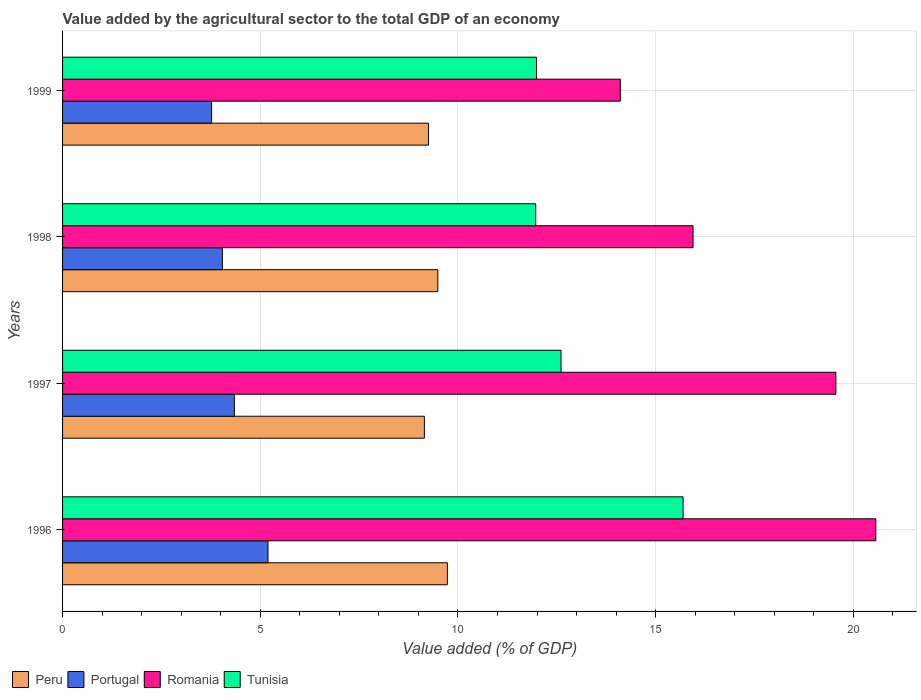Are the number of bars per tick equal to the number of legend labels?
Provide a short and direct response. Yes. Are the number of bars on each tick of the Y-axis equal?
Ensure brevity in your answer.  Yes. How many bars are there on the 1st tick from the top?
Make the answer very short. 4. What is the label of the 4th group of bars from the top?
Provide a short and direct response. 1996. In how many cases, is the number of bars for a given year not equal to the number of legend labels?
Give a very brief answer. 0. What is the value added by the agricultural sector to the total GDP in Romania in 1998?
Ensure brevity in your answer.  15.94. Across all years, what is the maximum value added by the agricultural sector to the total GDP in Tunisia?
Make the answer very short. 15.69. Across all years, what is the minimum value added by the agricultural sector to the total GDP in Tunisia?
Your response must be concise. 11.97. What is the total value added by the agricultural sector to the total GDP in Tunisia in the graph?
Give a very brief answer. 52.25. What is the difference between the value added by the agricultural sector to the total GDP in Portugal in 1996 and that in 1999?
Offer a terse response. 1.43. What is the difference between the value added by the agricultural sector to the total GDP in Peru in 1997 and the value added by the agricultural sector to the total GDP in Portugal in 1999?
Keep it short and to the point. 5.38. What is the average value added by the agricultural sector to the total GDP in Portugal per year?
Offer a terse response. 4.34. In the year 1998, what is the difference between the value added by the agricultural sector to the total GDP in Romania and value added by the agricultural sector to the total GDP in Peru?
Give a very brief answer. 6.45. What is the ratio of the value added by the agricultural sector to the total GDP in Tunisia in 1996 to that in 1998?
Offer a very short reply. 1.31. Is the difference between the value added by the agricultural sector to the total GDP in Romania in 1998 and 1999 greater than the difference between the value added by the agricultural sector to the total GDP in Peru in 1998 and 1999?
Provide a succinct answer. Yes. What is the difference between the highest and the second highest value added by the agricultural sector to the total GDP in Tunisia?
Give a very brief answer. 3.09. What is the difference between the highest and the lowest value added by the agricultural sector to the total GDP in Portugal?
Your answer should be compact. 1.43. Is the sum of the value added by the agricultural sector to the total GDP in Romania in 1998 and 1999 greater than the maximum value added by the agricultural sector to the total GDP in Peru across all years?
Make the answer very short. Yes. Is it the case that in every year, the sum of the value added by the agricultural sector to the total GDP in Romania and value added by the agricultural sector to the total GDP in Peru is greater than the sum of value added by the agricultural sector to the total GDP in Tunisia and value added by the agricultural sector to the total GDP in Portugal?
Give a very brief answer. Yes. What does the 2nd bar from the top in 1998 represents?
Make the answer very short. Romania. What does the 3rd bar from the bottom in 1996 represents?
Ensure brevity in your answer.  Romania. How many bars are there?
Your answer should be very brief. 16. Are all the bars in the graph horizontal?
Make the answer very short. Yes. How many years are there in the graph?
Ensure brevity in your answer.  4. What is the difference between two consecutive major ticks on the X-axis?
Provide a succinct answer. 5. Are the values on the major ticks of X-axis written in scientific E-notation?
Provide a succinct answer. No. Does the graph contain grids?
Your response must be concise. Yes. How are the legend labels stacked?
Make the answer very short. Horizontal. What is the title of the graph?
Your answer should be compact. Value added by the agricultural sector to the total GDP of an economy. What is the label or title of the X-axis?
Keep it short and to the point. Value added (% of GDP). What is the label or title of the Y-axis?
Your answer should be very brief. Years. What is the Value added (% of GDP) of Peru in 1996?
Give a very brief answer. 9.73. What is the Value added (% of GDP) of Portugal in 1996?
Your response must be concise. 5.2. What is the Value added (% of GDP) of Romania in 1996?
Your answer should be compact. 20.57. What is the Value added (% of GDP) of Tunisia in 1996?
Make the answer very short. 15.69. What is the Value added (% of GDP) in Peru in 1997?
Your answer should be very brief. 9.15. What is the Value added (% of GDP) of Portugal in 1997?
Provide a short and direct response. 4.34. What is the Value added (% of GDP) of Romania in 1997?
Offer a very short reply. 19.56. What is the Value added (% of GDP) in Tunisia in 1997?
Offer a very short reply. 12.61. What is the Value added (% of GDP) in Peru in 1998?
Ensure brevity in your answer.  9.49. What is the Value added (% of GDP) of Portugal in 1998?
Your answer should be very brief. 4.04. What is the Value added (% of GDP) in Romania in 1998?
Provide a succinct answer. 15.94. What is the Value added (% of GDP) in Tunisia in 1998?
Keep it short and to the point. 11.97. What is the Value added (% of GDP) in Peru in 1999?
Offer a terse response. 9.25. What is the Value added (% of GDP) of Portugal in 1999?
Offer a very short reply. 3.77. What is the Value added (% of GDP) in Romania in 1999?
Your response must be concise. 14.11. What is the Value added (% of GDP) in Tunisia in 1999?
Ensure brevity in your answer.  11.99. Across all years, what is the maximum Value added (% of GDP) of Peru?
Offer a terse response. 9.73. Across all years, what is the maximum Value added (% of GDP) in Portugal?
Provide a short and direct response. 5.2. Across all years, what is the maximum Value added (% of GDP) of Romania?
Provide a succinct answer. 20.57. Across all years, what is the maximum Value added (% of GDP) in Tunisia?
Provide a short and direct response. 15.69. Across all years, what is the minimum Value added (% of GDP) of Peru?
Your answer should be very brief. 9.15. Across all years, what is the minimum Value added (% of GDP) in Portugal?
Offer a terse response. 3.77. Across all years, what is the minimum Value added (% of GDP) of Romania?
Your response must be concise. 14.11. Across all years, what is the minimum Value added (% of GDP) in Tunisia?
Make the answer very short. 11.97. What is the total Value added (% of GDP) of Peru in the graph?
Your answer should be compact. 37.63. What is the total Value added (% of GDP) in Portugal in the graph?
Make the answer very short. 17.35. What is the total Value added (% of GDP) in Romania in the graph?
Ensure brevity in your answer.  70.18. What is the total Value added (% of GDP) of Tunisia in the graph?
Keep it short and to the point. 52.25. What is the difference between the Value added (% of GDP) in Peru in 1996 and that in 1997?
Provide a succinct answer. 0.58. What is the difference between the Value added (% of GDP) of Portugal in 1996 and that in 1997?
Ensure brevity in your answer.  0.85. What is the difference between the Value added (% of GDP) in Romania in 1996 and that in 1997?
Your answer should be compact. 1.01. What is the difference between the Value added (% of GDP) of Tunisia in 1996 and that in 1997?
Make the answer very short. 3.09. What is the difference between the Value added (% of GDP) in Peru in 1996 and that in 1998?
Your answer should be compact. 0.24. What is the difference between the Value added (% of GDP) in Portugal in 1996 and that in 1998?
Keep it short and to the point. 1.15. What is the difference between the Value added (% of GDP) in Romania in 1996 and that in 1998?
Your response must be concise. 4.62. What is the difference between the Value added (% of GDP) of Tunisia in 1996 and that in 1998?
Provide a short and direct response. 3.73. What is the difference between the Value added (% of GDP) of Peru in 1996 and that in 1999?
Give a very brief answer. 0.48. What is the difference between the Value added (% of GDP) of Portugal in 1996 and that in 1999?
Your response must be concise. 1.43. What is the difference between the Value added (% of GDP) in Romania in 1996 and that in 1999?
Make the answer very short. 6.46. What is the difference between the Value added (% of GDP) of Tunisia in 1996 and that in 1999?
Keep it short and to the point. 3.71. What is the difference between the Value added (% of GDP) of Peru in 1997 and that in 1998?
Make the answer very short. -0.34. What is the difference between the Value added (% of GDP) in Portugal in 1997 and that in 1998?
Your answer should be compact. 0.3. What is the difference between the Value added (% of GDP) of Romania in 1997 and that in 1998?
Keep it short and to the point. 3.61. What is the difference between the Value added (% of GDP) in Tunisia in 1997 and that in 1998?
Your answer should be very brief. 0.64. What is the difference between the Value added (% of GDP) in Peru in 1997 and that in 1999?
Make the answer very short. -0.1. What is the difference between the Value added (% of GDP) in Portugal in 1997 and that in 1999?
Your answer should be very brief. 0.58. What is the difference between the Value added (% of GDP) in Romania in 1997 and that in 1999?
Keep it short and to the point. 5.45. What is the difference between the Value added (% of GDP) of Tunisia in 1997 and that in 1999?
Your answer should be very brief. 0.62. What is the difference between the Value added (% of GDP) of Peru in 1998 and that in 1999?
Ensure brevity in your answer.  0.24. What is the difference between the Value added (% of GDP) of Portugal in 1998 and that in 1999?
Your answer should be very brief. 0.27. What is the difference between the Value added (% of GDP) of Romania in 1998 and that in 1999?
Your response must be concise. 1.84. What is the difference between the Value added (% of GDP) of Tunisia in 1998 and that in 1999?
Provide a succinct answer. -0.02. What is the difference between the Value added (% of GDP) in Peru in 1996 and the Value added (% of GDP) in Portugal in 1997?
Your answer should be very brief. 5.39. What is the difference between the Value added (% of GDP) of Peru in 1996 and the Value added (% of GDP) of Romania in 1997?
Provide a succinct answer. -9.83. What is the difference between the Value added (% of GDP) in Peru in 1996 and the Value added (% of GDP) in Tunisia in 1997?
Ensure brevity in your answer.  -2.87. What is the difference between the Value added (% of GDP) of Portugal in 1996 and the Value added (% of GDP) of Romania in 1997?
Offer a very short reply. -14.36. What is the difference between the Value added (% of GDP) in Portugal in 1996 and the Value added (% of GDP) in Tunisia in 1997?
Your answer should be very brief. -7.41. What is the difference between the Value added (% of GDP) of Romania in 1996 and the Value added (% of GDP) of Tunisia in 1997?
Offer a terse response. 7.96. What is the difference between the Value added (% of GDP) in Peru in 1996 and the Value added (% of GDP) in Portugal in 1998?
Your response must be concise. 5.69. What is the difference between the Value added (% of GDP) in Peru in 1996 and the Value added (% of GDP) in Romania in 1998?
Your answer should be very brief. -6.21. What is the difference between the Value added (% of GDP) of Peru in 1996 and the Value added (% of GDP) of Tunisia in 1998?
Give a very brief answer. -2.23. What is the difference between the Value added (% of GDP) in Portugal in 1996 and the Value added (% of GDP) in Romania in 1998?
Ensure brevity in your answer.  -10.75. What is the difference between the Value added (% of GDP) of Portugal in 1996 and the Value added (% of GDP) of Tunisia in 1998?
Your answer should be compact. -6.77. What is the difference between the Value added (% of GDP) in Romania in 1996 and the Value added (% of GDP) in Tunisia in 1998?
Ensure brevity in your answer.  8.6. What is the difference between the Value added (% of GDP) of Peru in 1996 and the Value added (% of GDP) of Portugal in 1999?
Your answer should be very brief. 5.96. What is the difference between the Value added (% of GDP) of Peru in 1996 and the Value added (% of GDP) of Romania in 1999?
Your response must be concise. -4.37. What is the difference between the Value added (% of GDP) of Peru in 1996 and the Value added (% of GDP) of Tunisia in 1999?
Your answer should be very brief. -2.25. What is the difference between the Value added (% of GDP) in Portugal in 1996 and the Value added (% of GDP) in Romania in 1999?
Offer a terse response. -8.91. What is the difference between the Value added (% of GDP) in Portugal in 1996 and the Value added (% of GDP) in Tunisia in 1999?
Make the answer very short. -6.79. What is the difference between the Value added (% of GDP) of Romania in 1996 and the Value added (% of GDP) of Tunisia in 1999?
Your answer should be very brief. 8.58. What is the difference between the Value added (% of GDP) in Peru in 1997 and the Value added (% of GDP) in Portugal in 1998?
Provide a succinct answer. 5.11. What is the difference between the Value added (% of GDP) of Peru in 1997 and the Value added (% of GDP) of Romania in 1998?
Your answer should be compact. -6.79. What is the difference between the Value added (% of GDP) in Peru in 1997 and the Value added (% of GDP) in Tunisia in 1998?
Provide a short and direct response. -2.82. What is the difference between the Value added (% of GDP) of Portugal in 1997 and the Value added (% of GDP) of Romania in 1998?
Give a very brief answer. -11.6. What is the difference between the Value added (% of GDP) of Portugal in 1997 and the Value added (% of GDP) of Tunisia in 1998?
Your response must be concise. -7.62. What is the difference between the Value added (% of GDP) of Romania in 1997 and the Value added (% of GDP) of Tunisia in 1998?
Your answer should be very brief. 7.59. What is the difference between the Value added (% of GDP) of Peru in 1997 and the Value added (% of GDP) of Portugal in 1999?
Give a very brief answer. 5.38. What is the difference between the Value added (% of GDP) in Peru in 1997 and the Value added (% of GDP) in Romania in 1999?
Ensure brevity in your answer.  -4.96. What is the difference between the Value added (% of GDP) in Peru in 1997 and the Value added (% of GDP) in Tunisia in 1999?
Provide a short and direct response. -2.84. What is the difference between the Value added (% of GDP) of Portugal in 1997 and the Value added (% of GDP) of Romania in 1999?
Your answer should be compact. -9.76. What is the difference between the Value added (% of GDP) of Portugal in 1997 and the Value added (% of GDP) of Tunisia in 1999?
Offer a terse response. -7.64. What is the difference between the Value added (% of GDP) in Romania in 1997 and the Value added (% of GDP) in Tunisia in 1999?
Make the answer very short. 7.57. What is the difference between the Value added (% of GDP) of Peru in 1998 and the Value added (% of GDP) of Portugal in 1999?
Your answer should be very brief. 5.72. What is the difference between the Value added (% of GDP) of Peru in 1998 and the Value added (% of GDP) of Romania in 1999?
Your answer should be very brief. -4.62. What is the difference between the Value added (% of GDP) in Peru in 1998 and the Value added (% of GDP) in Tunisia in 1999?
Your response must be concise. -2.49. What is the difference between the Value added (% of GDP) in Portugal in 1998 and the Value added (% of GDP) in Romania in 1999?
Give a very brief answer. -10.06. What is the difference between the Value added (% of GDP) in Portugal in 1998 and the Value added (% of GDP) in Tunisia in 1999?
Ensure brevity in your answer.  -7.94. What is the difference between the Value added (% of GDP) of Romania in 1998 and the Value added (% of GDP) of Tunisia in 1999?
Make the answer very short. 3.96. What is the average Value added (% of GDP) of Peru per year?
Your response must be concise. 9.41. What is the average Value added (% of GDP) of Portugal per year?
Ensure brevity in your answer.  4.34. What is the average Value added (% of GDP) in Romania per year?
Provide a succinct answer. 17.54. What is the average Value added (% of GDP) of Tunisia per year?
Offer a very short reply. 13.06. In the year 1996, what is the difference between the Value added (% of GDP) of Peru and Value added (% of GDP) of Portugal?
Ensure brevity in your answer.  4.54. In the year 1996, what is the difference between the Value added (% of GDP) of Peru and Value added (% of GDP) of Romania?
Your response must be concise. -10.84. In the year 1996, what is the difference between the Value added (% of GDP) in Peru and Value added (% of GDP) in Tunisia?
Offer a very short reply. -5.96. In the year 1996, what is the difference between the Value added (% of GDP) of Portugal and Value added (% of GDP) of Romania?
Ensure brevity in your answer.  -15.37. In the year 1996, what is the difference between the Value added (% of GDP) of Portugal and Value added (% of GDP) of Tunisia?
Provide a short and direct response. -10.5. In the year 1996, what is the difference between the Value added (% of GDP) in Romania and Value added (% of GDP) in Tunisia?
Your response must be concise. 4.87. In the year 1997, what is the difference between the Value added (% of GDP) of Peru and Value added (% of GDP) of Portugal?
Keep it short and to the point. 4.81. In the year 1997, what is the difference between the Value added (% of GDP) in Peru and Value added (% of GDP) in Romania?
Your answer should be very brief. -10.41. In the year 1997, what is the difference between the Value added (% of GDP) in Peru and Value added (% of GDP) in Tunisia?
Provide a succinct answer. -3.46. In the year 1997, what is the difference between the Value added (% of GDP) in Portugal and Value added (% of GDP) in Romania?
Make the answer very short. -15.21. In the year 1997, what is the difference between the Value added (% of GDP) of Portugal and Value added (% of GDP) of Tunisia?
Give a very brief answer. -8.26. In the year 1997, what is the difference between the Value added (% of GDP) of Romania and Value added (% of GDP) of Tunisia?
Keep it short and to the point. 6.95. In the year 1998, what is the difference between the Value added (% of GDP) of Peru and Value added (% of GDP) of Portugal?
Offer a very short reply. 5.45. In the year 1998, what is the difference between the Value added (% of GDP) in Peru and Value added (% of GDP) in Romania?
Make the answer very short. -6.45. In the year 1998, what is the difference between the Value added (% of GDP) of Peru and Value added (% of GDP) of Tunisia?
Your answer should be very brief. -2.48. In the year 1998, what is the difference between the Value added (% of GDP) in Portugal and Value added (% of GDP) in Romania?
Keep it short and to the point. -11.9. In the year 1998, what is the difference between the Value added (% of GDP) in Portugal and Value added (% of GDP) in Tunisia?
Provide a short and direct response. -7.92. In the year 1998, what is the difference between the Value added (% of GDP) of Romania and Value added (% of GDP) of Tunisia?
Give a very brief answer. 3.98. In the year 1999, what is the difference between the Value added (% of GDP) in Peru and Value added (% of GDP) in Portugal?
Your response must be concise. 5.49. In the year 1999, what is the difference between the Value added (% of GDP) of Peru and Value added (% of GDP) of Romania?
Offer a very short reply. -4.85. In the year 1999, what is the difference between the Value added (% of GDP) of Peru and Value added (% of GDP) of Tunisia?
Give a very brief answer. -2.73. In the year 1999, what is the difference between the Value added (% of GDP) in Portugal and Value added (% of GDP) in Romania?
Your response must be concise. -10.34. In the year 1999, what is the difference between the Value added (% of GDP) in Portugal and Value added (% of GDP) in Tunisia?
Provide a short and direct response. -8.22. In the year 1999, what is the difference between the Value added (% of GDP) in Romania and Value added (% of GDP) in Tunisia?
Keep it short and to the point. 2.12. What is the ratio of the Value added (% of GDP) in Peru in 1996 to that in 1997?
Provide a succinct answer. 1.06. What is the ratio of the Value added (% of GDP) of Portugal in 1996 to that in 1997?
Provide a succinct answer. 1.2. What is the ratio of the Value added (% of GDP) of Romania in 1996 to that in 1997?
Provide a short and direct response. 1.05. What is the ratio of the Value added (% of GDP) in Tunisia in 1996 to that in 1997?
Offer a very short reply. 1.24. What is the ratio of the Value added (% of GDP) in Peru in 1996 to that in 1998?
Give a very brief answer. 1.03. What is the ratio of the Value added (% of GDP) in Portugal in 1996 to that in 1998?
Offer a terse response. 1.29. What is the ratio of the Value added (% of GDP) in Romania in 1996 to that in 1998?
Your answer should be very brief. 1.29. What is the ratio of the Value added (% of GDP) of Tunisia in 1996 to that in 1998?
Your response must be concise. 1.31. What is the ratio of the Value added (% of GDP) in Peru in 1996 to that in 1999?
Your answer should be very brief. 1.05. What is the ratio of the Value added (% of GDP) of Portugal in 1996 to that in 1999?
Provide a succinct answer. 1.38. What is the ratio of the Value added (% of GDP) in Romania in 1996 to that in 1999?
Your answer should be very brief. 1.46. What is the ratio of the Value added (% of GDP) of Tunisia in 1996 to that in 1999?
Your answer should be compact. 1.31. What is the ratio of the Value added (% of GDP) of Peru in 1997 to that in 1998?
Give a very brief answer. 0.96. What is the ratio of the Value added (% of GDP) of Portugal in 1997 to that in 1998?
Your answer should be very brief. 1.07. What is the ratio of the Value added (% of GDP) of Romania in 1997 to that in 1998?
Ensure brevity in your answer.  1.23. What is the ratio of the Value added (% of GDP) in Tunisia in 1997 to that in 1998?
Your answer should be compact. 1.05. What is the ratio of the Value added (% of GDP) in Portugal in 1997 to that in 1999?
Offer a terse response. 1.15. What is the ratio of the Value added (% of GDP) of Romania in 1997 to that in 1999?
Provide a short and direct response. 1.39. What is the ratio of the Value added (% of GDP) of Tunisia in 1997 to that in 1999?
Keep it short and to the point. 1.05. What is the ratio of the Value added (% of GDP) in Peru in 1998 to that in 1999?
Your answer should be very brief. 1.03. What is the ratio of the Value added (% of GDP) of Portugal in 1998 to that in 1999?
Provide a succinct answer. 1.07. What is the ratio of the Value added (% of GDP) in Romania in 1998 to that in 1999?
Keep it short and to the point. 1.13. What is the difference between the highest and the second highest Value added (% of GDP) in Peru?
Your answer should be very brief. 0.24. What is the difference between the highest and the second highest Value added (% of GDP) in Portugal?
Your answer should be very brief. 0.85. What is the difference between the highest and the second highest Value added (% of GDP) in Romania?
Your answer should be compact. 1.01. What is the difference between the highest and the second highest Value added (% of GDP) in Tunisia?
Provide a short and direct response. 3.09. What is the difference between the highest and the lowest Value added (% of GDP) in Peru?
Offer a terse response. 0.58. What is the difference between the highest and the lowest Value added (% of GDP) in Portugal?
Your answer should be very brief. 1.43. What is the difference between the highest and the lowest Value added (% of GDP) in Romania?
Keep it short and to the point. 6.46. What is the difference between the highest and the lowest Value added (% of GDP) of Tunisia?
Your response must be concise. 3.73. 